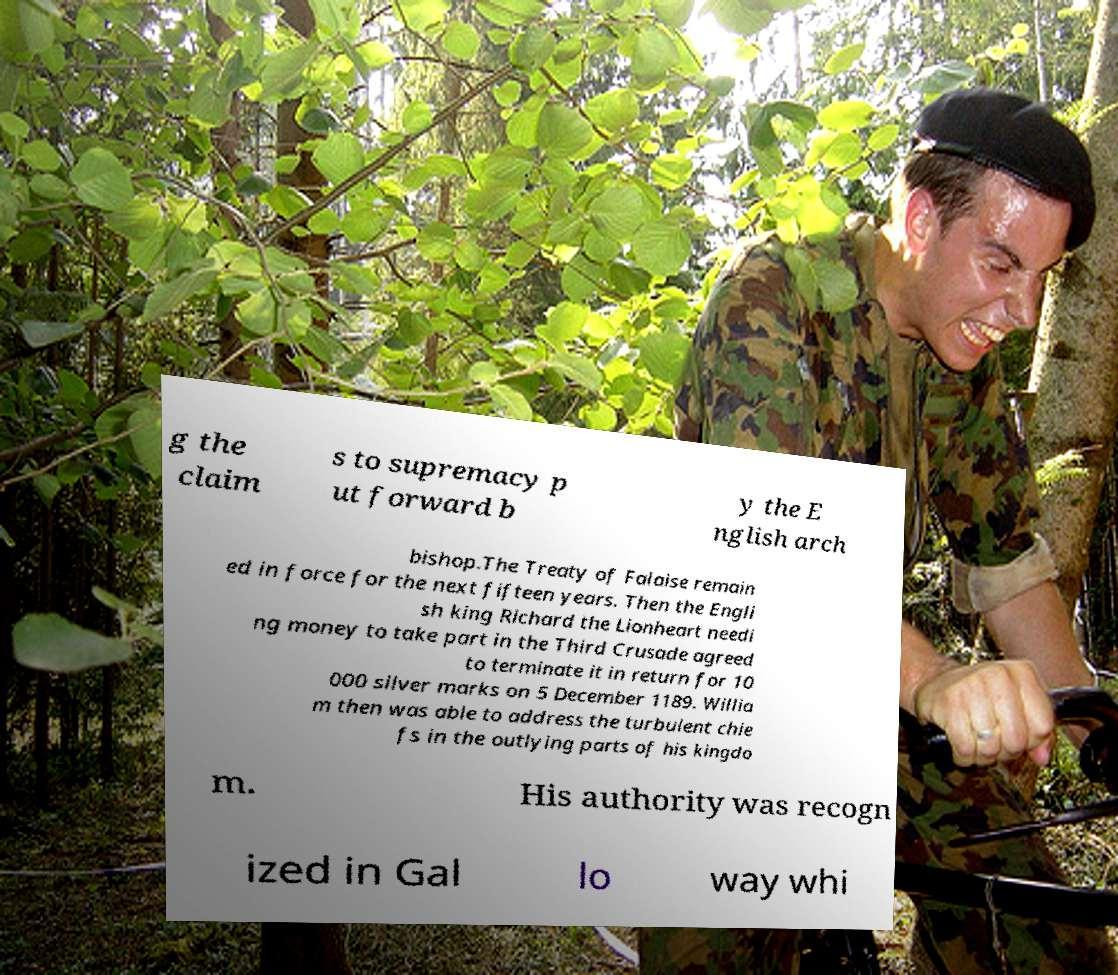I need the written content from this picture converted into text. Can you do that? g the claim s to supremacy p ut forward b y the E nglish arch bishop.The Treaty of Falaise remain ed in force for the next fifteen years. Then the Engli sh king Richard the Lionheart needi ng money to take part in the Third Crusade agreed to terminate it in return for 10 000 silver marks on 5 December 1189. Willia m then was able to address the turbulent chie fs in the outlying parts of his kingdo m. His authority was recogn ized in Gal lo way whi 